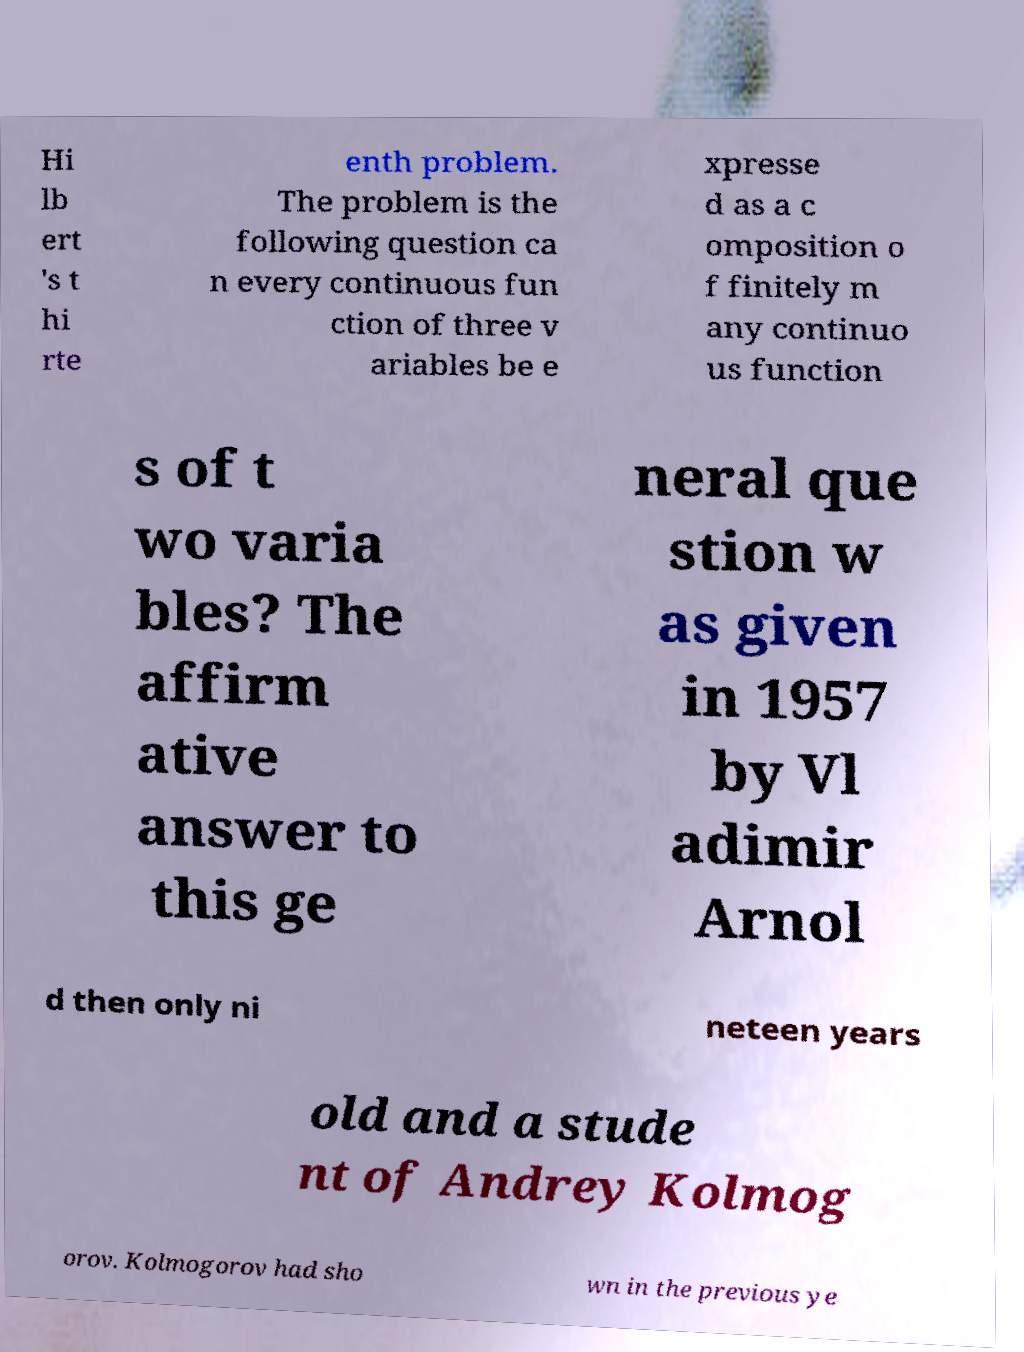There's text embedded in this image that I need extracted. Can you transcribe it verbatim? Hi lb ert 's t hi rte enth problem. The problem is the following question ca n every continuous fun ction of three v ariables be e xpresse d as a c omposition o f finitely m any continuo us function s of t wo varia bles? The affirm ative answer to this ge neral que stion w as given in 1957 by Vl adimir Arnol d then only ni neteen years old and a stude nt of Andrey Kolmog orov. Kolmogorov had sho wn in the previous ye 